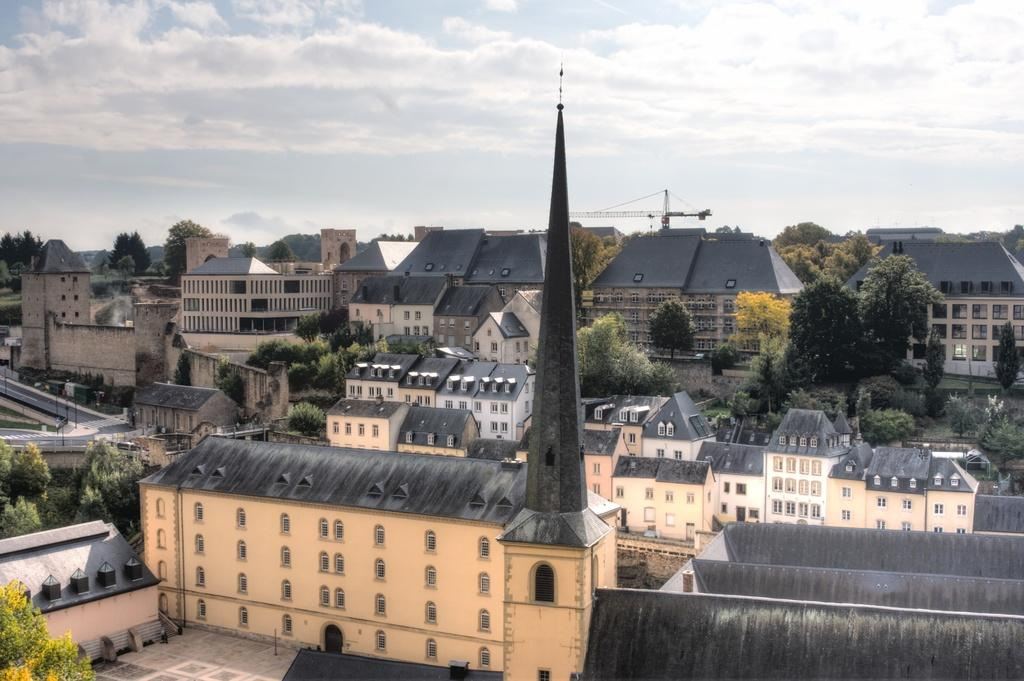What type of structures can be seen in the image? There are buildings in the image. What feature of the buildings is visible in the image? There are windows visible in the image. What type of vegetation is present in the image? There are trees in the image. What type of vertical structures can be seen in the image? There are poles in the image. What part of the natural environment is visible in the image? The sky is visible in the image. How does the image show the buildings caring for the trees? The image does not show the buildings caring for the trees; it simply depicts the presence of both structures and vegetation. 